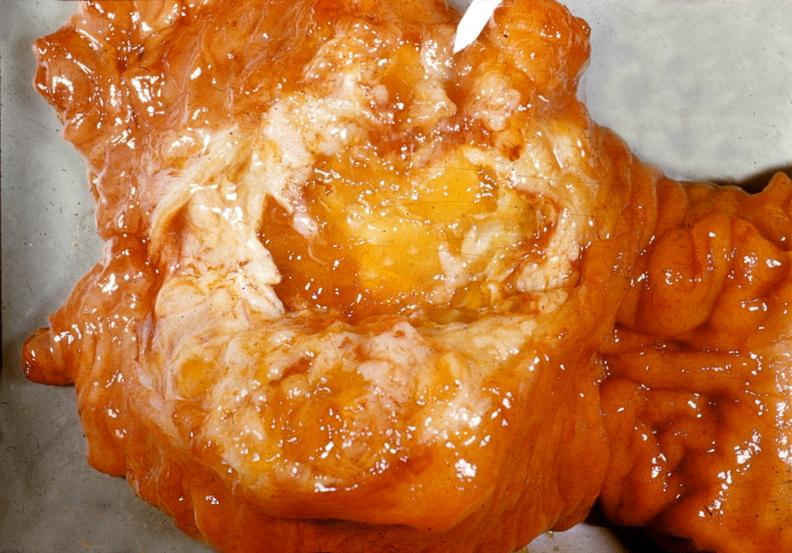does this image show adenocarcinoma, mucinous, head of pancreas?
Answer the question using a single word or phrase. Yes 